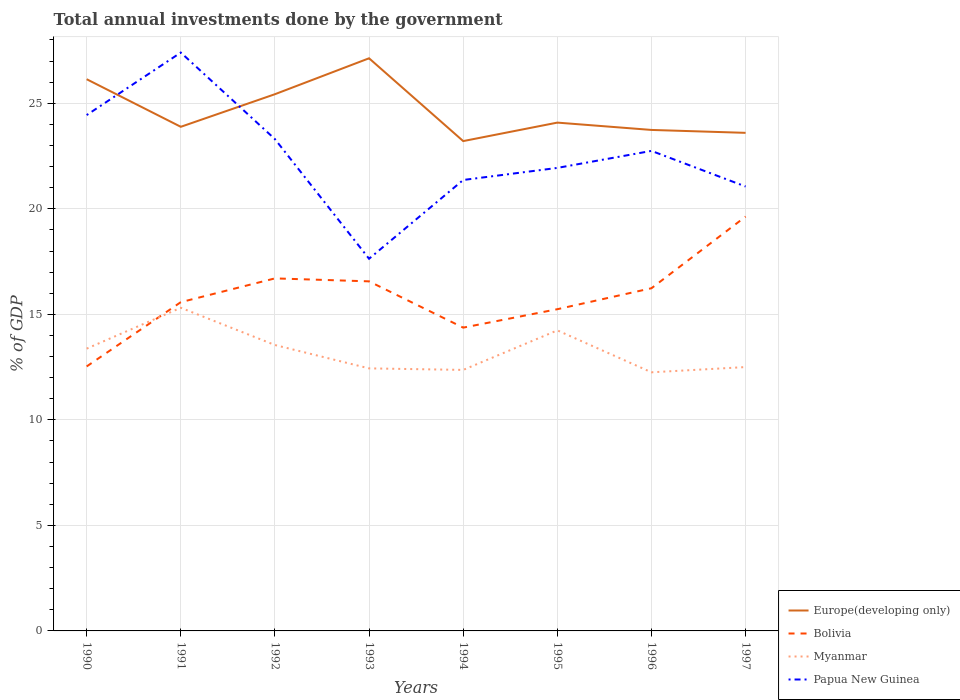Does the line corresponding to Papua New Guinea intersect with the line corresponding to Bolivia?
Make the answer very short. No. Across all years, what is the maximum total annual investments done by the government in Europe(developing only)?
Your response must be concise. 23.21. In which year was the total annual investments done by the government in Europe(developing only) maximum?
Give a very brief answer. 1994. What is the total total annual investments done by the government in Myanmar in the graph?
Your answer should be compact. 0.94. What is the difference between the highest and the second highest total annual investments done by the government in Papua New Guinea?
Offer a very short reply. 9.77. What is the difference between the highest and the lowest total annual investments done by the government in Bolivia?
Offer a very short reply. 4. Is the total annual investments done by the government in Myanmar strictly greater than the total annual investments done by the government in Papua New Guinea over the years?
Your answer should be very brief. Yes. How many years are there in the graph?
Keep it short and to the point. 8. Does the graph contain grids?
Your response must be concise. Yes. Where does the legend appear in the graph?
Keep it short and to the point. Bottom right. What is the title of the graph?
Ensure brevity in your answer.  Total annual investments done by the government. Does "Ecuador" appear as one of the legend labels in the graph?
Give a very brief answer. No. What is the label or title of the X-axis?
Your response must be concise. Years. What is the label or title of the Y-axis?
Your answer should be compact. % of GDP. What is the % of GDP in Europe(developing only) in 1990?
Provide a short and direct response. 26.14. What is the % of GDP of Bolivia in 1990?
Your answer should be very brief. 12.53. What is the % of GDP in Myanmar in 1990?
Your answer should be compact. 13.38. What is the % of GDP in Papua New Guinea in 1990?
Keep it short and to the point. 24.44. What is the % of GDP in Europe(developing only) in 1991?
Give a very brief answer. 23.89. What is the % of GDP of Bolivia in 1991?
Ensure brevity in your answer.  15.58. What is the % of GDP in Myanmar in 1991?
Ensure brevity in your answer.  15.31. What is the % of GDP in Papua New Guinea in 1991?
Your answer should be compact. 27.4. What is the % of GDP in Europe(developing only) in 1992?
Provide a succinct answer. 25.43. What is the % of GDP of Bolivia in 1992?
Give a very brief answer. 16.7. What is the % of GDP in Myanmar in 1992?
Give a very brief answer. 13.55. What is the % of GDP of Papua New Guinea in 1992?
Give a very brief answer. 23.3. What is the % of GDP in Europe(developing only) in 1993?
Your answer should be very brief. 27.13. What is the % of GDP of Bolivia in 1993?
Keep it short and to the point. 16.56. What is the % of GDP of Myanmar in 1993?
Give a very brief answer. 12.44. What is the % of GDP in Papua New Guinea in 1993?
Offer a terse response. 17.63. What is the % of GDP of Europe(developing only) in 1994?
Your answer should be compact. 23.21. What is the % of GDP in Bolivia in 1994?
Your answer should be compact. 14.37. What is the % of GDP of Myanmar in 1994?
Make the answer very short. 12.37. What is the % of GDP in Papua New Guinea in 1994?
Give a very brief answer. 21.37. What is the % of GDP of Europe(developing only) in 1995?
Offer a terse response. 24.09. What is the % of GDP of Bolivia in 1995?
Provide a short and direct response. 15.24. What is the % of GDP of Myanmar in 1995?
Keep it short and to the point. 14.24. What is the % of GDP of Papua New Guinea in 1995?
Offer a terse response. 21.94. What is the % of GDP in Europe(developing only) in 1996?
Keep it short and to the point. 23.74. What is the % of GDP in Bolivia in 1996?
Make the answer very short. 16.24. What is the % of GDP in Myanmar in 1996?
Provide a succinct answer. 12.25. What is the % of GDP in Papua New Guinea in 1996?
Your answer should be compact. 22.75. What is the % of GDP of Europe(developing only) in 1997?
Offer a very short reply. 23.6. What is the % of GDP of Bolivia in 1997?
Ensure brevity in your answer.  19.63. What is the % of GDP of Myanmar in 1997?
Offer a very short reply. 12.5. What is the % of GDP of Papua New Guinea in 1997?
Your answer should be very brief. 21.06. Across all years, what is the maximum % of GDP in Europe(developing only)?
Your answer should be compact. 27.13. Across all years, what is the maximum % of GDP of Bolivia?
Provide a short and direct response. 19.63. Across all years, what is the maximum % of GDP of Myanmar?
Offer a terse response. 15.31. Across all years, what is the maximum % of GDP in Papua New Guinea?
Make the answer very short. 27.4. Across all years, what is the minimum % of GDP in Europe(developing only)?
Offer a very short reply. 23.21. Across all years, what is the minimum % of GDP in Bolivia?
Provide a short and direct response. 12.53. Across all years, what is the minimum % of GDP in Myanmar?
Offer a very short reply. 12.25. Across all years, what is the minimum % of GDP in Papua New Guinea?
Provide a short and direct response. 17.63. What is the total % of GDP of Europe(developing only) in the graph?
Your response must be concise. 197.23. What is the total % of GDP of Bolivia in the graph?
Offer a terse response. 126.86. What is the total % of GDP of Myanmar in the graph?
Provide a succinct answer. 106.04. What is the total % of GDP of Papua New Guinea in the graph?
Offer a terse response. 179.89. What is the difference between the % of GDP in Europe(developing only) in 1990 and that in 1991?
Offer a very short reply. 2.26. What is the difference between the % of GDP in Bolivia in 1990 and that in 1991?
Offer a very short reply. -3.05. What is the difference between the % of GDP of Myanmar in 1990 and that in 1991?
Offer a terse response. -1.94. What is the difference between the % of GDP of Papua New Guinea in 1990 and that in 1991?
Offer a very short reply. -2.96. What is the difference between the % of GDP of Europe(developing only) in 1990 and that in 1992?
Your answer should be very brief. 0.71. What is the difference between the % of GDP in Bolivia in 1990 and that in 1992?
Your answer should be very brief. -4.17. What is the difference between the % of GDP of Myanmar in 1990 and that in 1992?
Your answer should be very brief. -0.17. What is the difference between the % of GDP of Papua New Guinea in 1990 and that in 1992?
Make the answer very short. 1.14. What is the difference between the % of GDP in Europe(developing only) in 1990 and that in 1993?
Your answer should be very brief. -0.99. What is the difference between the % of GDP of Bolivia in 1990 and that in 1993?
Your answer should be very brief. -4.03. What is the difference between the % of GDP of Myanmar in 1990 and that in 1993?
Your answer should be very brief. 0.94. What is the difference between the % of GDP of Papua New Guinea in 1990 and that in 1993?
Ensure brevity in your answer.  6.81. What is the difference between the % of GDP of Europe(developing only) in 1990 and that in 1994?
Make the answer very short. 2.93. What is the difference between the % of GDP of Bolivia in 1990 and that in 1994?
Your response must be concise. -1.84. What is the difference between the % of GDP in Papua New Guinea in 1990 and that in 1994?
Give a very brief answer. 3.08. What is the difference between the % of GDP in Europe(developing only) in 1990 and that in 1995?
Provide a succinct answer. 2.06. What is the difference between the % of GDP of Bolivia in 1990 and that in 1995?
Make the answer very short. -2.71. What is the difference between the % of GDP in Myanmar in 1990 and that in 1995?
Offer a very short reply. -0.87. What is the difference between the % of GDP in Papua New Guinea in 1990 and that in 1995?
Make the answer very short. 2.5. What is the difference between the % of GDP in Europe(developing only) in 1990 and that in 1996?
Make the answer very short. 2.4. What is the difference between the % of GDP in Bolivia in 1990 and that in 1996?
Offer a very short reply. -3.71. What is the difference between the % of GDP in Myanmar in 1990 and that in 1996?
Offer a terse response. 1.12. What is the difference between the % of GDP of Papua New Guinea in 1990 and that in 1996?
Keep it short and to the point. 1.7. What is the difference between the % of GDP in Europe(developing only) in 1990 and that in 1997?
Offer a very short reply. 2.54. What is the difference between the % of GDP of Myanmar in 1990 and that in 1997?
Make the answer very short. 0.87. What is the difference between the % of GDP in Papua New Guinea in 1990 and that in 1997?
Provide a short and direct response. 3.38. What is the difference between the % of GDP in Europe(developing only) in 1991 and that in 1992?
Offer a very short reply. -1.54. What is the difference between the % of GDP of Bolivia in 1991 and that in 1992?
Give a very brief answer. -1.13. What is the difference between the % of GDP in Myanmar in 1991 and that in 1992?
Make the answer very short. 1.76. What is the difference between the % of GDP in Papua New Guinea in 1991 and that in 1992?
Provide a short and direct response. 4.1. What is the difference between the % of GDP in Europe(developing only) in 1991 and that in 1993?
Your answer should be very brief. -3.25. What is the difference between the % of GDP of Bolivia in 1991 and that in 1993?
Ensure brevity in your answer.  -0.99. What is the difference between the % of GDP of Myanmar in 1991 and that in 1993?
Provide a short and direct response. 2.87. What is the difference between the % of GDP in Papua New Guinea in 1991 and that in 1993?
Your response must be concise. 9.77. What is the difference between the % of GDP of Europe(developing only) in 1991 and that in 1994?
Your response must be concise. 0.68. What is the difference between the % of GDP in Bolivia in 1991 and that in 1994?
Your answer should be compact. 1.21. What is the difference between the % of GDP in Myanmar in 1991 and that in 1994?
Ensure brevity in your answer.  2.94. What is the difference between the % of GDP of Papua New Guinea in 1991 and that in 1994?
Make the answer very short. 6.04. What is the difference between the % of GDP of Europe(developing only) in 1991 and that in 1995?
Ensure brevity in your answer.  -0.2. What is the difference between the % of GDP in Bolivia in 1991 and that in 1995?
Offer a terse response. 0.33. What is the difference between the % of GDP of Myanmar in 1991 and that in 1995?
Make the answer very short. 1.07. What is the difference between the % of GDP in Papua New Guinea in 1991 and that in 1995?
Give a very brief answer. 5.47. What is the difference between the % of GDP in Europe(developing only) in 1991 and that in 1996?
Your answer should be very brief. 0.15. What is the difference between the % of GDP of Bolivia in 1991 and that in 1996?
Your answer should be very brief. -0.66. What is the difference between the % of GDP of Myanmar in 1991 and that in 1996?
Ensure brevity in your answer.  3.06. What is the difference between the % of GDP of Papua New Guinea in 1991 and that in 1996?
Offer a very short reply. 4.66. What is the difference between the % of GDP of Europe(developing only) in 1991 and that in 1997?
Offer a very short reply. 0.29. What is the difference between the % of GDP in Bolivia in 1991 and that in 1997?
Keep it short and to the point. -4.05. What is the difference between the % of GDP in Myanmar in 1991 and that in 1997?
Your answer should be compact. 2.81. What is the difference between the % of GDP in Papua New Guinea in 1991 and that in 1997?
Keep it short and to the point. 6.35. What is the difference between the % of GDP of Europe(developing only) in 1992 and that in 1993?
Your response must be concise. -1.7. What is the difference between the % of GDP in Bolivia in 1992 and that in 1993?
Provide a succinct answer. 0.14. What is the difference between the % of GDP in Myanmar in 1992 and that in 1993?
Ensure brevity in your answer.  1.11. What is the difference between the % of GDP of Papua New Guinea in 1992 and that in 1993?
Keep it short and to the point. 5.67. What is the difference between the % of GDP of Europe(developing only) in 1992 and that in 1994?
Your answer should be compact. 2.22. What is the difference between the % of GDP of Bolivia in 1992 and that in 1994?
Your response must be concise. 2.33. What is the difference between the % of GDP in Myanmar in 1992 and that in 1994?
Make the answer very short. 1.18. What is the difference between the % of GDP in Papua New Guinea in 1992 and that in 1994?
Keep it short and to the point. 1.94. What is the difference between the % of GDP in Europe(developing only) in 1992 and that in 1995?
Offer a very short reply. 1.35. What is the difference between the % of GDP of Bolivia in 1992 and that in 1995?
Provide a succinct answer. 1.46. What is the difference between the % of GDP of Myanmar in 1992 and that in 1995?
Your answer should be compact. -0.69. What is the difference between the % of GDP of Papua New Guinea in 1992 and that in 1995?
Ensure brevity in your answer.  1.36. What is the difference between the % of GDP in Europe(developing only) in 1992 and that in 1996?
Offer a terse response. 1.69. What is the difference between the % of GDP in Bolivia in 1992 and that in 1996?
Provide a succinct answer. 0.47. What is the difference between the % of GDP in Myanmar in 1992 and that in 1996?
Keep it short and to the point. 1.29. What is the difference between the % of GDP in Papua New Guinea in 1992 and that in 1996?
Offer a very short reply. 0.56. What is the difference between the % of GDP in Europe(developing only) in 1992 and that in 1997?
Provide a short and direct response. 1.83. What is the difference between the % of GDP of Bolivia in 1992 and that in 1997?
Provide a short and direct response. -2.93. What is the difference between the % of GDP in Myanmar in 1992 and that in 1997?
Your answer should be compact. 1.04. What is the difference between the % of GDP in Papua New Guinea in 1992 and that in 1997?
Give a very brief answer. 2.25. What is the difference between the % of GDP of Europe(developing only) in 1993 and that in 1994?
Offer a very short reply. 3.92. What is the difference between the % of GDP in Bolivia in 1993 and that in 1994?
Provide a succinct answer. 2.19. What is the difference between the % of GDP of Myanmar in 1993 and that in 1994?
Provide a short and direct response. 0.07. What is the difference between the % of GDP in Papua New Guinea in 1993 and that in 1994?
Give a very brief answer. -3.73. What is the difference between the % of GDP in Europe(developing only) in 1993 and that in 1995?
Your response must be concise. 3.05. What is the difference between the % of GDP in Bolivia in 1993 and that in 1995?
Give a very brief answer. 1.32. What is the difference between the % of GDP in Myanmar in 1993 and that in 1995?
Offer a very short reply. -1.8. What is the difference between the % of GDP in Papua New Guinea in 1993 and that in 1995?
Provide a succinct answer. -4.3. What is the difference between the % of GDP of Europe(developing only) in 1993 and that in 1996?
Give a very brief answer. 3.4. What is the difference between the % of GDP of Bolivia in 1993 and that in 1996?
Provide a succinct answer. 0.33. What is the difference between the % of GDP in Myanmar in 1993 and that in 1996?
Make the answer very short. 0.19. What is the difference between the % of GDP of Papua New Guinea in 1993 and that in 1996?
Give a very brief answer. -5.11. What is the difference between the % of GDP of Europe(developing only) in 1993 and that in 1997?
Your response must be concise. 3.53. What is the difference between the % of GDP in Bolivia in 1993 and that in 1997?
Ensure brevity in your answer.  -3.07. What is the difference between the % of GDP in Myanmar in 1993 and that in 1997?
Provide a short and direct response. -0.06. What is the difference between the % of GDP in Papua New Guinea in 1993 and that in 1997?
Ensure brevity in your answer.  -3.42. What is the difference between the % of GDP of Europe(developing only) in 1994 and that in 1995?
Ensure brevity in your answer.  -0.88. What is the difference between the % of GDP in Bolivia in 1994 and that in 1995?
Provide a short and direct response. -0.87. What is the difference between the % of GDP in Myanmar in 1994 and that in 1995?
Provide a succinct answer. -1.87. What is the difference between the % of GDP of Papua New Guinea in 1994 and that in 1995?
Offer a very short reply. -0.57. What is the difference between the % of GDP of Europe(developing only) in 1994 and that in 1996?
Keep it short and to the point. -0.53. What is the difference between the % of GDP of Bolivia in 1994 and that in 1996?
Your answer should be compact. -1.87. What is the difference between the % of GDP in Myanmar in 1994 and that in 1996?
Provide a succinct answer. 0.11. What is the difference between the % of GDP of Papua New Guinea in 1994 and that in 1996?
Give a very brief answer. -1.38. What is the difference between the % of GDP in Europe(developing only) in 1994 and that in 1997?
Your answer should be very brief. -0.39. What is the difference between the % of GDP in Bolivia in 1994 and that in 1997?
Offer a very short reply. -5.26. What is the difference between the % of GDP in Myanmar in 1994 and that in 1997?
Make the answer very short. -0.13. What is the difference between the % of GDP in Papua New Guinea in 1994 and that in 1997?
Your response must be concise. 0.31. What is the difference between the % of GDP of Europe(developing only) in 1995 and that in 1996?
Offer a terse response. 0.35. What is the difference between the % of GDP in Bolivia in 1995 and that in 1996?
Offer a terse response. -0.99. What is the difference between the % of GDP of Myanmar in 1995 and that in 1996?
Make the answer very short. 1.99. What is the difference between the % of GDP in Papua New Guinea in 1995 and that in 1996?
Your answer should be very brief. -0.81. What is the difference between the % of GDP of Europe(developing only) in 1995 and that in 1997?
Your answer should be very brief. 0.48. What is the difference between the % of GDP of Bolivia in 1995 and that in 1997?
Make the answer very short. -4.39. What is the difference between the % of GDP of Myanmar in 1995 and that in 1997?
Your answer should be compact. 1.74. What is the difference between the % of GDP of Papua New Guinea in 1995 and that in 1997?
Offer a terse response. 0.88. What is the difference between the % of GDP of Europe(developing only) in 1996 and that in 1997?
Provide a succinct answer. 0.14. What is the difference between the % of GDP in Bolivia in 1996 and that in 1997?
Make the answer very short. -3.39. What is the difference between the % of GDP in Myanmar in 1996 and that in 1997?
Your answer should be very brief. -0.25. What is the difference between the % of GDP of Papua New Guinea in 1996 and that in 1997?
Your answer should be very brief. 1.69. What is the difference between the % of GDP in Europe(developing only) in 1990 and the % of GDP in Bolivia in 1991?
Provide a succinct answer. 10.56. What is the difference between the % of GDP in Europe(developing only) in 1990 and the % of GDP in Myanmar in 1991?
Offer a very short reply. 10.83. What is the difference between the % of GDP of Europe(developing only) in 1990 and the % of GDP of Papua New Guinea in 1991?
Give a very brief answer. -1.26. What is the difference between the % of GDP of Bolivia in 1990 and the % of GDP of Myanmar in 1991?
Your answer should be very brief. -2.78. What is the difference between the % of GDP in Bolivia in 1990 and the % of GDP in Papua New Guinea in 1991?
Ensure brevity in your answer.  -14.87. What is the difference between the % of GDP in Myanmar in 1990 and the % of GDP in Papua New Guinea in 1991?
Your response must be concise. -14.03. What is the difference between the % of GDP of Europe(developing only) in 1990 and the % of GDP of Bolivia in 1992?
Provide a succinct answer. 9.44. What is the difference between the % of GDP of Europe(developing only) in 1990 and the % of GDP of Myanmar in 1992?
Keep it short and to the point. 12.6. What is the difference between the % of GDP of Europe(developing only) in 1990 and the % of GDP of Papua New Guinea in 1992?
Provide a succinct answer. 2.84. What is the difference between the % of GDP in Bolivia in 1990 and the % of GDP in Myanmar in 1992?
Provide a succinct answer. -1.02. What is the difference between the % of GDP in Bolivia in 1990 and the % of GDP in Papua New Guinea in 1992?
Provide a succinct answer. -10.77. What is the difference between the % of GDP of Myanmar in 1990 and the % of GDP of Papua New Guinea in 1992?
Provide a short and direct response. -9.93. What is the difference between the % of GDP of Europe(developing only) in 1990 and the % of GDP of Bolivia in 1993?
Your answer should be very brief. 9.58. What is the difference between the % of GDP in Europe(developing only) in 1990 and the % of GDP in Myanmar in 1993?
Your answer should be very brief. 13.7. What is the difference between the % of GDP of Europe(developing only) in 1990 and the % of GDP of Papua New Guinea in 1993?
Keep it short and to the point. 8.51. What is the difference between the % of GDP in Bolivia in 1990 and the % of GDP in Myanmar in 1993?
Offer a terse response. 0.09. What is the difference between the % of GDP in Bolivia in 1990 and the % of GDP in Papua New Guinea in 1993?
Make the answer very short. -5.1. What is the difference between the % of GDP in Myanmar in 1990 and the % of GDP in Papua New Guinea in 1993?
Keep it short and to the point. -4.26. What is the difference between the % of GDP of Europe(developing only) in 1990 and the % of GDP of Bolivia in 1994?
Ensure brevity in your answer.  11.77. What is the difference between the % of GDP in Europe(developing only) in 1990 and the % of GDP in Myanmar in 1994?
Ensure brevity in your answer.  13.77. What is the difference between the % of GDP of Europe(developing only) in 1990 and the % of GDP of Papua New Guinea in 1994?
Keep it short and to the point. 4.78. What is the difference between the % of GDP of Bolivia in 1990 and the % of GDP of Myanmar in 1994?
Give a very brief answer. 0.16. What is the difference between the % of GDP in Bolivia in 1990 and the % of GDP in Papua New Guinea in 1994?
Your answer should be compact. -8.83. What is the difference between the % of GDP in Myanmar in 1990 and the % of GDP in Papua New Guinea in 1994?
Provide a short and direct response. -7.99. What is the difference between the % of GDP of Europe(developing only) in 1990 and the % of GDP of Bolivia in 1995?
Ensure brevity in your answer.  10.9. What is the difference between the % of GDP of Europe(developing only) in 1990 and the % of GDP of Myanmar in 1995?
Keep it short and to the point. 11.9. What is the difference between the % of GDP of Europe(developing only) in 1990 and the % of GDP of Papua New Guinea in 1995?
Your answer should be compact. 4.2. What is the difference between the % of GDP in Bolivia in 1990 and the % of GDP in Myanmar in 1995?
Make the answer very short. -1.71. What is the difference between the % of GDP of Bolivia in 1990 and the % of GDP of Papua New Guinea in 1995?
Make the answer very short. -9.41. What is the difference between the % of GDP in Myanmar in 1990 and the % of GDP in Papua New Guinea in 1995?
Your answer should be very brief. -8.56. What is the difference between the % of GDP in Europe(developing only) in 1990 and the % of GDP in Bolivia in 1996?
Offer a very short reply. 9.9. What is the difference between the % of GDP of Europe(developing only) in 1990 and the % of GDP of Myanmar in 1996?
Provide a short and direct response. 13.89. What is the difference between the % of GDP of Europe(developing only) in 1990 and the % of GDP of Papua New Guinea in 1996?
Offer a terse response. 3.4. What is the difference between the % of GDP in Bolivia in 1990 and the % of GDP in Myanmar in 1996?
Offer a very short reply. 0.28. What is the difference between the % of GDP of Bolivia in 1990 and the % of GDP of Papua New Guinea in 1996?
Your answer should be very brief. -10.21. What is the difference between the % of GDP of Myanmar in 1990 and the % of GDP of Papua New Guinea in 1996?
Give a very brief answer. -9.37. What is the difference between the % of GDP of Europe(developing only) in 1990 and the % of GDP of Bolivia in 1997?
Provide a succinct answer. 6.51. What is the difference between the % of GDP of Europe(developing only) in 1990 and the % of GDP of Myanmar in 1997?
Offer a very short reply. 13.64. What is the difference between the % of GDP in Europe(developing only) in 1990 and the % of GDP in Papua New Guinea in 1997?
Your answer should be compact. 5.08. What is the difference between the % of GDP of Bolivia in 1990 and the % of GDP of Myanmar in 1997?
Your answer should be very brief. 0.03. What is the difference between the % of GDP in Bolivia in 1990 and the % of GDP in Papua New Guinea in 1997?
Your answer should be very brief. -8.53. What is the difference between the % of GDP of Myanmar in 1990 and the % of GDP of Papua New Guinea in 1997?
Offer a very short reply. -7.68. What is the difference between the % of GDP of Europe(developing only) in 1991 and the % of GDP of Bolivia in 1992?
Offer a very short reply. 7.18. What is the difference between the % of GDP of Europe(developing only) in 1991 and the % of GDP of Myanmar in 1992?
Your answer should be very brief. 10.34. What is the difference between the % of GDP in Europe(developing only) in 1991 and the % of GDP in Papua New Guinea in 1992?
Ensure brevity in your answer.  0.58. What is the difference between the % of GDP in Bolivia in 1991 and the % of GDP in Myanmar in 1992?
Offer a very short reply. 2.03. What is the difference between the % of GDP of Bolivia in 1991 and the % of GDP of Papua New Guinea in 1992?
Offer a very short reply. -7.73. What is the difference between the % of GDP in Myanmar in 1991 and the % of GDP in Papua New Guinea in 1992?
Offer a very short reply. -7.99. What is the difference between the % of GDP of Europe(developing only) in 1991 and the % of GDP of Bolivia in 1993?
Make the answer very short. 7.32. What is the difference between the % of GDP in Europe(developing only) in 1991 and the % of GDP in Myanmar in 1993?
Keep it short and to the point. 11.45. What is the difference between the % of GDP of Europe(developing only) in 1991 and the % of GDP of Papua New Guinea in 1993?
Give a very brief answer. 6.25. What is the difference between the % of GDP in Bolivia in 1991 and the % of GDP in Myanmar in 1993?
Offer a very short reply. 3.14. What is the difference between the % of GDP of Bolivia in 1991 and the % of GDP of Papua New Guinea in 1993?
Your answer should be very brief. -2.06. What is the difference between the % of GDP in Myanmar in 1991 and the % of GDP in Papua New Guinea in 1993?
Keep it short and to the point. -2.32. What is the difference between the % of GDP of Europe(developing only) in 1991 and the % of GDP of Bolivia in 1994?
Offer a terse response. 9.52. What is the difference between the % of GDP of Europe(developing only) in 1991 and the % of GDP of Myanmar in 1994?
Offer a very short reply. 11.52. What is the difference between the % of GDP of Europe(developing only) in 1991 and the % of GDP of Papua New Guinea in 1994?
Make the answer very short. 2.52. What is the difference between the % of GDP of Bolivia in 1991 and the % of GDP of Myanmar in 1994?
Ensure brevity in your answer.  3.21. What is the difference between the % of GDP in Bolivia in 1991 and the % of GDP in Papua New Guinea in 1994?
Your response must be concise. -5.79. What is the difference between the % of GDP in Myanmar in 1991 and the % of GDP in Papua New Guinea in 1994?
Ensure brevity in your answer.  -6.05. What is the difference between the % of GDP of Europe(developing only) in 1991 and the % of GDP of Bolivia in 1995?
Offer a very short reply. 8.64. What is the difference between the % of GDP of Europe(developing only) in 1991 and the % of GDP of Myanmar in 1995?
Keep it short and to the point. 9.65. What is the difference between the % of GDP in Europe(developing only) in 1991 and the % of GDP in Papua New Guinea in 1995?
Your answer should be compact. 1.95. What is the difference between the % of GDP of Bolivia in 1991 and the % of GDP of Myanmar in 1995?
Your response must be concise. 1.34. What is the difference between the % of GDP in Bolivia in 1991 and the % of GDP in Papua New Guinea in 1995?
Keep it short and to the point. -6.36. What is the difference between the % of GDP of Myanmar in 1991 and the % of GDP of Papua New Guinea in 1995?
Your answer should be compact. -6.63. What is the difference between the % of GDP in Europe(developing only) in 1991 and the % of GDP in Bolivia in 1996?
Ensure brevity in your answer.  7.65. What is the difference between the % of GDP of Europe(developing only) in 1991 and the % of GDP of Myanmar in 1996?
Your answer should be compact. 11.63. What is the difference between the % of GDP of Europe(developing only) in 1991 and the % of GDP of Papua New Guinea in 1996?
Give a very brief answer. 1.14. What is the difference between the % of GDP of Bolivia in 1991 and the % of GDP of Myanmar in 1996?
Offer a very short reply. 3.32. What is the difference between the % of GDP in Bolivia in 1991 and the % of GDP in Papua New Guinea in 1996?
Offer a very short reply. -7.17. What is the difference between the % of GDP in Myanmar in 1991 and the % of GDP in Papua New Guinea in 1996?
Give a very brief answer. -7.43. What is the difference between the % of GDP in Europe(developing only) in 1991 and the % of GDP in Bolivia in 1997?
Make the answer very short. 4.25. What is the difference between the % of GDP in Europe(developing only) in 1991 and the % of GDP in Myanmar in 1997?
Offer a very short reply. 11.38. What is the difference between the % of GDP of Europe(developing only) in 1991 and the % of GDP of Papua New Guinea in 1997?
Offer a terse response. 2.83. What is the difference between the % of GDP of Bolivia in 1991 and the % of GDP of Myanmar in 1997?
Provide a short and direct response. 3.08. What is the difference between the % of GDP of Bolivia in 1991 and the % of GDP of Papua New Guinea in 1997?
Make the answer very short. -5.48. What is the difference between the % of GDP in Myanmar in 1991 and the % of GDP in Papua New Guinea in 1997?
Provide a short and direct response. -5.75. What is the difference between the % of GDP of Europe(developing only) in 1992 and the % of GDP of Bolivia in 1993?
Your answer should be compact. 8.87. What is the difference between the % of GDP of Europe(developing only) in 1992 and the % of GDP of Myanmar in 1993?
Provide a succinct answer. 12.99. What is the difference between the % of GDP of Europe(developing only) in 1992 and the % of GDP of Papua New Guinea in 1993?
Give a very brief answer. 7.8. What is the difference between the % of GDP in Bolivia in 1992 and the % of GDP in Myanmar in 1993?
Keep it short and to the point. 4.26. What is the difference between the % of GDP of Bolivia in 1992 and the % of GDP of Papua New Guinea in 1993?
Your answer should be compact. -0.93. What is the difference between the % of GDP in Myanmar in 1992 and the % of GDP in Papua New Guinea in 1993?
Make the answer very short. -4.09. What is the difference between the % of GDP of Europe(developing only) in 1992 and the % of GDP of Bolivia in 1994?
Provide a succinct answer. 11.06. What is the difference between the % of GDP of Europe(developing only) in 1992 and the % of GDP of Myanmar in 1994?
Your response must be concise. 13.06. What is the difference between the % of GDP in Europe(developing only) in 1992 and the % of GDP in Papua New Guinea in 1994?
Your response must be concise. 4.06. What is the difference between the % of GDP of Bolivia in 1992 and the % of GDP of Myanmar in 1994?
Provide a succinct answer. 4.34. What is the difference between the % of GDP of Bolivia in 1992 and the % of GDP of Papua New Guinea in 1994?
Keep it short and to the point. -4.66. What is the difference between the % of GDP of Myanmar in 1992 and the % of GDP of Papua New Guinea in 1994?
Give a very brief answer. -7.82. What is the difference between the % of GDP in Europe(developing only) in 1992 and the % of GDP in Bolivia in 1995?
Provide a short and direct response. 10.19. What is the difference between the % of GDP of Europe(developing only) in 1992 and the % of GDP of Myanmar in 1995?
Keep it short and to the point. 11.19. What is the difference between the % of GDP in Europe(developing only) in 1992 and the % of GDP in Papua New Guinea in 1995?
Your response must be concise. 3.49. What is the difference between the % of GDP in Bolivia in 1992 and the % of GDP in Myanmar in 1995?
Offer a very short reply. 2.46. What is the difference between the % of GDP in Bolivia in 1992 and the % of GDP in Papua New Guinea in 1995?
Offer a very short reply. -5.23. What is the difference between the % of GDP in Myanmar in 1992 and the % of GDP in Papua New Guinea in 1995?
Give a very brief answer. -8.39. What is the difference between the % of GDP of Europe(developing only) in 1992 and the % of GDP of Bolivia in 1996?
Offer a terse response. 9.19. What is the difference between the % of GDP in Europe(developing only) in 1992 and the % of GDP in Myanmar in 1996?
Your answer should be very brief. 13.18. What is the difference between the % of GDP in Europe(developing only) in 1992 and the % of GDP in Papua New Guinea in 1996?
Your response must be concise. 2.69. What is the difference between the % of GDP in Bolivia in 1992 and the % of GDP in Myanmar in 1996?
Offer a terse response. 4.45. What is the difference between the % of GDP in Bolivia in 1992 and the % of GDP in Papua New Guinea in 1996?
Ensure brevity in your answer.  -6.04. What is the difference between the % of GDP in Myanmar in 1992 and the % of GDP in Papua New Guinea in 1996?
Keep it short and to the point. -9.2. What is the difference between the % of GDP of Europe(developing only) in 1992 and the % of GDP of Bolivia in 1997?
Offer a very short reply. 5.8. What is the difference between the % of GDP in Europe(developing only) in 1992 and the % of GDP in Myanmar in 1997?
Offer a terse response. 12.93. What is the difference between the % of GDP in Europe(developing only) in 1992 and the % of GDP in Papua New Guinea in 1997?
Make the answer very short. 4.37. What is the difference between the % of GDP of Bolivia in 1992 and the % of GDP of Myanmar in 1997?
Give a very brief answer. 4.2. What is the difference between the % of GDP of Bolivia in 1992 and the % of GDP of Papua New Guinea in 1997?
Offer a terse response. -4.35. What is the difference between the % of GDP in Myanmar in 1992 and the % of GDP in Papua New Guinea in 1997?
Provide a succinct answer. -7.51. What is the difference between the % of GDP in Europe(developing only) in 1993 and the % of GDP in Bolivia in 1994?
Give a very brief answer. 12.76. What is the difference between the % of GDP of Europe(developing only) in 1993 and the % of GDP of Myanmar in 1994?
Provide a succinct answer. 14.77. What is the difference between the % of GDP in Europe(developing only) in 1993 and the % of GDP in Papua New Guinea in 1994?
Your answer should be very brief. 5.77. What is the difference between the % of GDP in Bolivia in 1993 and the % of GDP in Myanmar in 1994?
Your response must be concise. 4.2. What is the difference between the % of GDP in Bolivia in 1993 and the % of GDP in Papua New Guinea in 1994?
Ensure brevity in your answer.  -4.8. What is the difference between the % of GDP in Myanmar in 1993 and the % of GDP in Papua New Guinea in 1994?
Make the answer very short. -8.93. What is the difference between the % of GDP in Europe(developing only) in 1993 and the % of GDP in Bolivia in 1995?
Offer a terse response. 11.89. What is the difference between the % of GDP of Europe(developing only) in 1993 and the % of GDP of Myanmar in 1995?
Ensure brevity in your answer.  12.89. What is the difference between the % of GDP in Europe(developing only) in 1993 and the % of GDP in Papua New Guinea in 1995?
Provide a short and direct response. 5.19. What is the difference between the % of GDP of Bolivia in 1993 and the % of GDP of Myanmar in 1995?
Ensure brevity in your answer.  2.32. What is the difference between the % of GDP in Bolivia in 1993 and the % of GDP in Papua New Guinea in 1995?
Your answer should be very brief. -5.38. What is the difference between the % of GDP in Myanmar in 1993 and the % of GDP in Papua New Guinea in 1995?
Keep it short and to the point. -9.5. What is the difference between the % of GDP in Europe(developing only) in 1993 and the % of GDP in Bolivia in 1996?
Your answer should be compact. 10.9. What is the difference between the % of GDP of Europe(developing only) in 1993 and the % of GDP of Myanmar in 1996?
Offer a terse response. 14.88. What is the difference between the % of GDP of Europe(developing only) in 1993 and the % of GDP of Papua New Guinea in 1996?
Provide a short and direct response. 4.39. What is the difference between the % of GDP of Bolivia in 1993 and the % of GDP of Myanmar in 1996?
Your answer should be very brief. 4.31. What is the difference between the % of GDP of Bolivia in 1993 and the % of GDP of Papua New Guinea in 1996?
Provide a short and direct response. -6.18. What is the difference between the % of GDP of Myanmar in 1993 and the % of GDP of Papua New Guinea in 1996?
Provide a succinct answer. -10.3. What is the difference between the % of GDP of Europe(developing only) in 1993 and the % of GDP of Bolivia in 1997?
Ensure brevity in your answer.  7.5. What is the difference between the % of GDP in Europe(developing only) in 1993 and the % of GDP in Myanmar in 1997?
Ensure brevity in your answer.  14.63. What is the difference between the % of GDP in Europe(developing only) in 1993 and the % of GDP in Papua New Guinea in 1997?
Ensure brevity in your answer.  6.08. What is the difference between the % of GDP in Bolivia in 1993 and the % of GDP in Myanmar in 1997?
Make the answer very short. 4.06. What is the difference between the % of GDP in Bolivia in 1993 and the % of GDP in Papua New Guinea in 1997?
Your answer should be compact. -4.49. What is the difference between the % of GDP in Myanmar in 1993 and the % of GDP in Papua New Guinea in 1997?
Provide a short and direct response. -8.62. What is the difference between the % of GDP in Europe(developing only) in 1994 and the % of GDP in Bolivia in 1995?
Provide a short and direct response. 7.97. What is the difference between the % of GDP of Europe(developing only) in 1994 and the % of GDP of Myanmar in 1995?
Your response must be concise. 8.97. What is the difference between the % of GDP in Europe(developing only) in 1994 and the % of GDP in Papua New Guinea in 1995?
Keep it short and to the point. 1.27. What is the difference between the % of GDP in Bolivia in 1994 and the % of GDP in Myanmar in 1995?
Your answer should be very brief. 0.13. What is the difference between the % of GDP in Bolivia in 1994 and the % of GDP in Papua New Guinea in 1995?
Your answer should be compact. -7.57. What is the difference between the % of GDP in Myanmar in 1994 and the % of GDP in Papua New Guinea in 1995?
Make the answer very short. -9.57. What is the difference between the % of GDP in Europe(developing only) in 1994 and the % of GDP in Bolivia in 1996?
Offer a terse response. 6.97. What is the difference between the % of GDP of Europe(developing only) in 1994 and the % of GDP of Myanmar in 1996?
Keep it short and to the point. 10.96. What is the difference between the % of GDP of Europe(developing only) in 1994 and the % of GDP of Papua New Guinea in 1996?
Keep it short and to the point. 0.46. What is the difference between the % of GDP of Bolivia in 1994 and the % of GDP of Myanmar in 1996?
Make the answer very short. 2.12. What is the difference between the % of GDP in Bolivia in 1994 and the % of GDP in Papua New Guinea in 1996?
Keep it short and to the point. -8.37. What is the difference between the % of GDP of Myanmar in 1994 and the % of GDP of Papua New Guinea in 1996?
Your answer should be compact. -10.38. What is the difference between the % of GDP of Europe(developing only) in 1994 and the % of GDP of Bolivia in 1997?
Keep it short and to the point. 3.58. What is the difference between the % of GDP in Europe(developing only) in 1994 and the % of GDP in Myanmar in 1997?
Give a very brief answer. 10.71. What is the difference between the % of GDP of Europe(developing only) in 1994 and the % of GDP of Papua New Guinea in 1997?
Your answer should be very brief. 2.15. What is the difference between the % of GDP in Bolivia in 1994 and the % of GDP in Myanmar in 1997?
Make the answer very short. 1.87. What is the difference between the % of GDP in Bolivia in 1994 and the % of GDP in Papua New Guinea in 1997?
Provide a succinct answer. -6.69. What is the difference between the % of GDP in Myanmar in 1994 and the % of GDP in Papua New Guinea in 1997?
Provide a short and direct response. -8.69. What is the difference between the % of GDP of Europe(developing only) in 1995 and the % of GDP of Bolivia in 1996?
Your answer should be compact. 7.85. What is the difference between the % of GDP of Europe(developing only) in 1995 and the % of GDP of Myanmar in 1996?
Your answer should be very brief. 11.83. What is the difference between the % of GDP in Europe(developing only) in 1995 and the % of GDP in Papua New Guinea in 1996?
Your response must be concise. 1.34. What is the difference between the % of GDP in Bolivia in 1995 and the % of GDP in Myanmar in 1996?
Provide a short and direct response. 2.99. What is the difference between the % of GDP in Bolivia in 1995 and the % of GDP in Papua New Guinea in 1996?
Keep it short and to the point. -7.5. What is the difference between the % of GDP in Myanmar in 1995 and the % of GDP in Papua New Guinea in 1996?
Your answer should be compact. -8.5. What is the difference between the % of GDP of Europe(developing only) in 1995 and the % of GDP of Bolivia in 1997?
Your response must be concise. 4.45. What is the difference between the % of GDP in Europe(developing only) in 1995 and the % of GDP in Myanmar in 1997?
Ensure brevity in your answer.  11.58. What is the difference between the % of GDP in Europe(developing only) in 1995 and the % of GDP in Papua New Guinea in 1997?
Offer a very short reply. 3.03. What is the difference between the % of GDP of Bolivia in 1995 and the % of GDP of Myanmar in 1997?
Offer a very short reply. 2.74. What is the difference between the % of GDP of Bolivia in 1995 and the % of GDP of Papua New Guinea in 1997?
Offer a very short reply. -5.81. What is the difference between the % of GDP of Myanmar in 1995 and the % of GDP of Papua New Guinea in 1997?
Provide a succinct answer. -6.82. What is the difference between the % of GDP of Europe(developing only) in 1996 and the % of GDP of Bolivia in 1997?
Make the answer very short. 4.11. What is the difference between the % of GDP of Europe(developing only) in 1996 and the % of GDP of Myanmar in 1997?
Give a very brief answer. 11.24. What is the difference between the % of GDP of Europe(developing only) in 1996 and the % of GDP of Papua New Guinea in 1997?
Offer a terse response. 2.68. What is the difference between the % of GDP in Bolivia in 1996 and the % of GDP in Myanmar in 1997?
Provide a succinct answer. 3.73. What is the difference between the % of GDP in Bolivia in 1996 and the % of GDP in Papua New Guinea in 1997?
Provide a short and direct response. -4.82. What is the difference between the % of GDP in Myanmar in 1996 and the % of GDP in Papua New Guinea in 1997?
Keep it short and to the point. -8.8. What is the average % of GDP of Europe(developing only) per year?
Your answer should be compact. 24.65. What is the average % of GDP in Bolivia per year?
Offer a very short reply. 15.86. What is the average % of GDP of Myanmar per year?
Provide a short and direct response. 13.26. What is the average % of GDP of Papua New Guinea per year?
Provide a short and direct response. 22.49. In the year 1990, what is the difference between the % of GDP of Europe(developing only) and % of GDP of Bolivia?
Your answer should be compact. 13.61. In the year 1990, what is the difference between the % of GDP of Europe(developing only) and % of GDP of Myanmar?
Provide a succinct answer. 12.77. In the year 1990, what is the difference between the % of GDP in Europe(developing only) and % of GDP in Papua New Guinea?
Ensure brevity in your answer.  1.7. In the year 1990, what is the difference between the % of GDP of Bolivia and % of GDP of Myanmar?
Your answer should be very brief. -0.84. In the year 1990, what is the difference between the % of GDP of Bolivia and % of GDP of Papua New Guinea?
Keep it short and to the point. -11.91. In the year 1990, what is the difference between the % of GDP in Myanmar and % of GDP in Papua New Guinea?
Give a very brief answer. -11.07. In the year 1991, what is the difference between the % of GDP in Europe(developing only) and % of GDP in Bolivia?
Give a very brief answer. 8.31. In the year 1991, what is the difference between the % of GDP of Europe(developing only) and % of GDP of Myanmar?
Make the answer very short. 8.57. In the year 1991, what is the difference between the % of GDP of Europe(developing only) and % of GDP of Papua New Guinea?
Provide a succinct answer. -3.52. In the year 1991, what is the difference between the % of GDP of Bolivia and % of GDP of Myanmar?
Provide a short and direct response. 0.27. In the year 1991, what is the difference between the % of GDP in Bolivia and % of GDP in Papua New Guinea?
Offer a very short reply. -11.83. In the year 1991, what is the difference between the % of GDP of Myanmar and % of GDP of Papua New Guinea?
Your answer should be compact. -12.09. In the year 1992, what is the difference between the % of GDP of Europe(developing only) and % of GDP of Bolivia?
Your answer should be very brief. 8.73. In the year 1992, what is the difference between the % of GDP in Europe(developing only) and % of GDP in Myanmar?
Provide a succinct answer. 11.88. In the year 1992, what is the difference between the % of GDP in Europe(developing only) and % of GDP in Papua New Guinea?
Offer a terse response. 2.13. In the year 1992, what is the difference between the % of GDP of Bolivia and % of GDP of Myanmar?
Your answer should be compact. 3.16. In the year 1992, what is the difference between the % of GDP of Bolivia and % of GDP of Papua New Guinea?
Keep it short and to the point. -6.6. In the year 1992, what is the difference between the % of GDP in Myanmar and % of GDP in Papua New Guinea?
Your answer should be compact. -9.76. In the year 1993, what is the difference between the % of GDP of Europe(developing only) and % of GDP of Bolivia?
Offer a very short reply. 10.57. In the year 1993, what is the difference between the % of GDP in Europe(developing only) and % of GDP in Myanmar?
Ensure brevity in your answer.  14.69. In the year 1993, what is the difference between the % of GDP of Europe(developing only) and % of GDP of Papua New Guinea?
Make the answer very short. 9.5. In the year 1993, what is the difference between the % of GDP in Bolivia and % of GDP in Myanmar?
Keep it short and to the point. 4.12. In the year 1993, what is the difference between the % of GDP in Bolivia and % of GDP in Papua New Guinea?
Offer a terse response. -1.07. In the year 1993, what is the difference between the % of GDP in Myanmar and % of GDP in Papua New Guinea?
Your answer should be compact. -5.19. In the year 1994, what is the difference between the % of GDP of Europe(developing only) and % of GDP of Bolivia?
Make the answer very short. 8.84. In the year 1994, what is the difference between the % of GDP in Europe(developing only) and % of GDP in Myanmar?
Provide a short and direct response. 10.84. In the year 1994, what is the difference between the % of GDP of Europe(developing only) and % of GDP of Papua New Guinea?
Your answer should be compact. 1.84. In the year 1994, what is the difference between the % of GDP of Bolivia and % of GDP of Myanmar?
Your answer should be very brief. 2. In the year 1994, what is the difference between the % of GDP of Bolivia and % of GDP of Papua New Guinea?
Make the answer very short. -7. In the year 1994, what is the difference between the % of GDP of Myanmar and % of GDP of Papua New Guinea?
Offer a very short reply. -9. In the year 1995, what is the difference between the % of GDP in Europe(developing only) and % of GDP in Bolivia?
Offer a very short reply. 8.84. In the year 1995, what is the difference between the % of GDP in Europe(developing only) and % of GDP in Myanmar?
Keep it short and to the point. 9.84. In the year 1995, what is the difference between the % of GDP of Europe(developing only) and % of GDP of Papua New Guinea?
Keep it short and to the point. 2.15. In the year 1995, what is the difference between the % of GDP in Bolivia and % of GDP in Papua New Guinea?
Your answer should be compact. -6.7. In the year 1995, what is the difference between the % of GDP in Myanmar and % of GDP in Papua New Guinea?
Your answer should be compact. -7.7. In the year 1996, what is the difference between the % of GDP of Europe(developing only) and % of GDP of Bolivia?
Make the answer very short. 7.5. In the year 1996, what is the difference between the % of GDP in Europe(developing only) and % of GDP in Myanmar?
Make the answer very short. 11.48. In the year 1996, what is the difference between the % of GDP of Europe(developing only) and % of GDP of Papua New Guinea?
Keep it short and to the point. 0.99. In the year 1996, what is the difference between the % of GDP of Bolivia and % of GDP of Myanmar?
Keep it short and to the point. 3.98. In the year 1996, what is the difference between the % of GDP of Bolivia and % of GDP of Papua New Guinea?
Ensure brevity in your answer.  -6.51. In the year 1996, what is the difference between the % of GDP in Myanmar and % of GDP in Papua New Guinea?
Provide a short and direct response. -10.49. In the year 1997, what is the difference between the % of GDP in Europe(developing only) and % of GDP in Bolivia?
Your response must be concise. 3.97. In the year 1997, what is the difference between the % of GDP of Europe(developing only) and % of GDP of Myanmar?
Provide a succinct answer. 11.1. In the year 1997, what is the difference between the % of GDP of Europe(developing only) and % of GDP of Papua New Guinea?
Give a very brief answer. 2.54. In the year 1997, what is the difference between the % of GDP in Bolivia and % of GDP in Myanmar?
Give a very brief answer. 7.13. In the year 1997, what is the difference between the % of GDP of Bolivia and % of GDP of Papua New Guinea?
Make the answer very short. -1.43. In the year 1997, what is the difference between the % of GDP of Myanmar and % of GDP of Papua New Guinea?
Provide a succinct answer. -8.56. What is the ratio of the % of GDP in Europe(developing only) in 1990 to that in 1991?
Your answer should be very brief. 1.09. What is the ratio of the % of GDP in Bolivia in 1990 to that in 1991?
Provide a short and direct response. 0.8. What is the ratio of the % of GDP of Myanmar in 1990 to that in 1991?
Offer a very short reply. 0.87. What is the ratio of the % of GDP of Papua New Guinea in 1990 to that in 1991?
Provide a short and direct response. 0.89. What is the ratio of the % of GDP of Europe(developing only) in 1990 to that in 1992?
Your response must be concise. 1.03. What is the ratio of the % of GDP in Bolivia in 1990 to that in 1992?
Your answer should be compact. 0.75. What is the ratio of the % of GDP in Myanmar in 1990 to that in 1992?
Give a very brief answer. 0.99. What is the ratio of the % of GDP of Papua New Guinea in 1990 to that in 1992?
Your response must be concise. 1.05. What is the ratio of the % of GDP of Europe(developing only) in 1990 to that in 1993?
Offer a very short reply. 0.96. What is the ratio of the % of GDP of Bolivia in 1990 to that in 1993?
Provide a succinct answer. 0.76. What is the ratio of the % of GDP in Myanmar in 1990 to that in 1993?
Your answer should be compact. 1.08. What is the ratio of the % of GDP in Papua New Guinea in 1990 to that in 1993?
Provide a succinct answer. 1.39. What is the ratio of the % of GDP of Europe(developing only) in 1990 to that in 1994?
Your response must be concise. 1.13. What is the ratio of the % of GDP in Bolivia in 1990 to that in 1994?
Provide a short and direct response. 0.87. What is the ratio of the % of GDP of Myanmar in 1990 to that in 1994?
Your answer should be compact. 1.08. What is the ratio of the % of GDP of Papua New Guinea in 1990 to that in 1994?
Offer a very short reply. 1.14. What is the ratio of the % of GDP in Europe(developing only) in 1990 to that in 1995?
Offer a terse response. 1.09. What is the ratio of the % of GDP in Bolivia in 1990 to that in 1995?
Provide a succinct answer. 0.82. What is the ratio of the % of GDP of Myanmar in 1990 to that in 1995?
Keep it short and to the point. 0.94. What is the ratio of the % of GDP of Papua New Guinea in 1990 to that in 1995?
Make the answer very short. 1.11. What is the ratio of the % of GDP of Europe(developing only) in 1990 to that in 1996?
Make the answer very short. 1.1. What is the ratio of the % of GDP in Bolivia in 1990 to that in 1996?
Provide a short and direct response. 0.77. What is the ratio of the % of GDP of Myanmar in 1990 to that in 1996?
Offer a terse response. 1.09. What is the ratio of the % of GDP in Papua New Guinea in 1990 to that in 1996?
Your answer should be compact. 1.07. What is the ratio of the % of GDP of Europe(developing only) in 1990 to that in 1997?
Ensure brevity in your answer.  1.11. What is the ratio of the % of GDP of Bolivia in 1990 to that in 1997?
Provide a short and direct response. 0.64. What is the ratio of the % of GDP of Myanmar in 1990 to that in 1997?
Your answer should be very brief. 1.07. What is the ratio of the % of GDP of Papua New Guinea in 1990 to that in 1997?
Provide a short and direct response. 1.16. What is the ratio of the % of GDP of Europe(developing only) in 1991 to that in 1992?
Your answer should be very brief. 0.94. What is the ratio of the % of GDP in Bolivia in 1991 to that in 1992?
Provide a short and direct response. 0.93. What is the ratio of the % of GDP of Myanmar in 1991 to that in 1992?
Your answer should be compact. 1.13. What is the ratio of the % of GDP of Papua New Guinea in 1991 to that in 1992?
Your response must be concise. 1.18. What is the ratio of the % of GDP in Europe(developing only) in 1991 to that in 1993?
Your answer should be compact. 0.88. What is the ratio of the % of GDP of Bolivia in 1991 to that in 1993?
Offer a very short reply. 0.94. What is the ratio of the % of GDP of Myanmar in 1991 to that in 1993?
Give a very brief answer. 1.23. What is the ratio of the % of GDP of Papua New Guinea in 1991 to that in 1993?
Your answer should be compact. 1.55. What is the ratio of the % of GDP of Europe(developing only) in 1991 to that in 1994?
Make the answer very short. 1.03. What is the ratio of the % of GDP of Bolivia in 1991 to that in 1994?
Offer a terse response. 1.08. What is the ratio of the % of GDP of Myanmar in 1991 to that in 1994?
Your answer should be very brief. 1.24. What is the ratio of the % of GDP in Papua New Guinea in 1991 to that in 1994?
Offer a terse response. 1.28. What is the ratio of the % of GDP in Europe(developing only) in 1991 to that in 1995?
Keep it short and to the point. 0.99. What is the ratio of the % of GDP of Bolivia in 1991 to that in 1995?
Ensure brevity in your answer.  1.02. What is the ratio of the % of GDP in Myanmar in 1991 to that in 1995?
Offer a very short reply. 1.08. What is the ratio of the % of GDP of Papua New Guinea in 1991 to that in 1995?
Ensure brevity in your answer.  1.25. What is the ratio of the % of GDP of Europe(developing only) in 1991 to that in 1996?
Offer a very short reply. 1.01. What is the ratio of the % of GDP of Bolivia in 1991 to that in 1996?
Provide a succinct answer. 0.96. What is the ratio of the % of GDP in Myanmar in 1991 to that in 1996?
Your response must be concise. 1.25. What is the ratio of the % of GDP of Papua New Guinea in 1991 to that in 1996?
Your answer should be very brief. 1.2. What is the ratio of the % of GDP in Europe(developing only) in 1991 to that in 1997?
Offer a very short reply. 1.01. What is the ratio of the % of GDP in Bolivia in 1991 to that in 1997?
Offer a terse response. 0.79. What is the ratio of the % of GDP in Myanmar in 1991 to that in 1997?
Offer a very short reply. 1.22. What is the ratio of the % of GDP of Papua New Guinea in 1991 to that in 1997?
Provide a succinct answer. 1.3. What is the ratio of the % of GDP in Europe(developing only) in 1992 to that in 1993?
Make the answer very short. 0.94. What is the ratio of the % of GDP in Bolivia in 1992 to that in 1993?
Make the answer very short. 1.01. What is the ratio of the % of GDP of Myanmar in 1992 to that in 1993?
Make the answer very short. 1.09. What is the ratio of the % of GDP of Papua New Guinea in 1992 to that in 1993?
Offer a very short reply. 1.32. What is the ratio of the % of GDP in Europe(developing only) in 1992 to that in 1994?
Your answer should be compact. 1.1. What is the ratio of the % of GDP in Bolivia in 1992 to that in 1994?
Provide a short and direct response. 1.16. What is the ratio of the % of GDP in Myanmar in 1992 to that in 1994?
Give a very brief answer. 1.1. What is the ratio of the % of GDP of Papua New Guinea in 1992 to that in 1994?
Your answer should be very brief. 1.09. What is the ratio of the % of GDP in Europe(developing only) in 1992 to that in 1995?
Give a very brief answer. 1.06. What is the ratio of the % of GDP in Bolivia in 1992 to that in 1995?
Make the answer very short. 1.1. What is the ratio of the % of GDP of Myanmar in 1992 to that in 1995?
Your answer should be very brief. 0.95. What is the ratio of the % of GDP in Papua New Guinea in 1992 to that in 1995?
Keep it short and to the point. 1.06. What is the ratio of the % of GDP of Europe(developing only) in 1992 to that in 1996?
Keep it short and to the point. 1.07. What is the ratio of the % of GDP of Bolivia in 1992 to that in 1996?
Provide a succinct answer. 1.03. What is the ratio of the % of GDP of Myanmar in 1992 to that in 1996?
Offer a terse response. 1.11. What is the ratio of the % of GDP of Papua New Guinea in 1992 to that in 1996?
Offer a terse response. 1.02. What is the ratio of the % of GDP of Europe(developing only) in 1992 to that in 1997?
Offer a very short reply. 1.08. What is the ratio of the % of GDP in Bolivia in 1992 to that in 1997?
Give a very brief answer. 0.85. What is the ratio of the % of GDP in Myanmar in 1992 to that in 1997?
Offer a very short reply. 1.08. What is the ratio of the % of GDP of Papua New Guinea in 1992 to that in 1997?
Offer a very short reply. 1.11. What is the ratio of the % of GDP of Europe(developing only) in 1993 to that in 1994?
Keep it short and to the point. 1.17. What is the ratio of the % of GDP in Bolivia in 1993 to that in 1994?
Give a very brief answer. 1.15. What is the ratio of the % of GDP in Myanmar in 1993 to that in 1994?
Provide a succinct answer. 1.01. What is the ratio of the % of GDP in Papua New Guinea in 1993 to that in 1994?
Your answer should be very brief. 0.83. What is the ratio of the % of GDP in Europe(developing only) in 1993 to that in 1995?
Ensure brevity in your answer.  1.13. What is the ratio of the % of GDP of Bolivia in 1993 to that in 1995?
Offer a very short reply. 1.09. What is the ratio of the % of GDP in Myanmar in 1993 to that in 1995?
Your answer should be very brief. 0.87. What is the ratio of the % of GDP of Papua New Guinea in 1993 to that in 1995?
Provide a short and direct response. 0.8. What is the ratio of the % of GDP of Europe(developing only) in 1993 to that in 1996?
Ensure brevity in your answer.  1.14. What is the ratio of the % of GDP in Bolivia in 1993 to that in 1996?
Offer a terse response. 1.02. What is the ratio of the % of GDP of Myanmar in 1993 to that in 1996?
Make the answer very short. 1.02. What is the ratio of the % of GDP of Papua New Guinea in 1993 to that in 1996?
Offer a very short reply. 0.78. What is the ratio of the % of GDP of Europe(developing only) in 1993 to that in 1997?
Your answer should be compact. 1.15. What is the ratio of the % of GDP in Bolivia in 1993 to that in 1997?
Offer a very short reply. 0.84. What is the ratio of the % of GDP in Myanmar in 1993 to that in 1997?
Your answer should be very brief. 1. What is the ratio of the % of GDP in Papua New Guinea in 1993 to that in 1997?
Provide a succinct answer. 0.84. What is the ratio of the % of GDP in Europe(developing only) in 1994 to that in 1995?
Your response must be concise. 0.96. What is the ratio of the % of GDP of Bolivia in 1994 to that in 1995?
Your answer should be very brief. 0.94. What is the ratio of the % of GDP in Myanmar in 1994 to that in 1995?
Make the answer very short. 0.87. What is the ratio of the % of GDP of Papua New Guinea in 1994 to that in 1995?
Ensure brevity in your answer.  0.97. What is the ratio of the % of GDP of Europe(developing only) in 1994 to that in 1996?
Make the answer very short. 0.98. What is the ratio of the % of GDP of Bolivia in 1994 to that in 1996?
Offer a terse response. 0.89. What is the ratio of the % of GDP in Myanmar in 1994 to that in 1996?
Keep it short and to the point. 1.01. What is the ratio of the % of GDP of Papua New Guinea in 1994 to that in 1996?
Your response must be concise. 0.94. What is the ratio of the % of GDP of Europe(developing only) in 1994 to that in 1997?
Offer a terse response. 0.98. What is the ratio of the % of GDP of Bolivia in 1994 to that in 1997?
Offer a terse response. 0.73. What is the ratio of the % of GDP of Myanmar in 1994 to that in 1997?
Give a very brief answer. 0.99. What is the ratio of the % of GDP in Papua New Guinea in 1994 to that in 1997?
Make the answer very short. 1.01. What is the ratio of the % of GDP in Europe(developing only) in 1995 to that in 1996?
Provide a succinct answer. 1.01. What is the ratio of the % of GDP of Bolivia in 1995 to that in 1996?
Your response must be concise. 0.94. What is the ratio of the % of GDP of Myanmar in 1995 to that in 1996?
Your answer should be very brief. 1.16. What is the ratio of the % of GDP of Papua New Guinea in 1995 to that in 1996?
Ensure brevity in your answer.  0.96. What is the ratio of the % of GDP in Europe(developing only) in 1995 to that in 1997?
Your response must be concise. 1.02. What is the ratio of the % of GDP in Bolivia in 1995 to that in 1997?
Provide a short and direct response. 0.78. What is the ratio of the % of GDP in Myanmar in 1995 to that in 1997?
Your answer should be compact. 1.14. What is the ratio of the % of GDP in Papua New Guinea in 1995 to that in 1997?
Offer a very short reply. 1.04. What is the ratio of the % of GDP of Bolivia in 1996 to that in 1997?
Your answer should be very brief. 0.83. What is the ratio of the % of GDP of Myanmar in 1996 to that in 1997?
Provide a short and direct response. 0.98. What is the ratio of the % of GDP in Papua New Guinea in 1996 to that in 1997?
Provide a short and direct response. 1.08. What is the difference between the highest and the second highest % of GDP in Europe(developing only)?
Your answer should be compact. 0.99. What is the difference between the highest and the second highest % of GDP in Bolivia?
Make the answer very short. 2.93. What is the difference between the highest and the second highest % of GDP in Myanmar?
Provide a short and direct response. 1.07. What is the difference between the highest and the second highest % of GDP of Papua New Guinea?
Your answer should be compact. 2.96. What is the difference between the highest and the lowest % of GDP of Europe(developing only)?
Make the answer very short. 3.92. What is the difference between the highest and the lowest % of GDP in Bolivia?
Offer a terse response. 7.1. What is the difference between the highest and the lowest % of GDP in Myanmar?
Offer a very short reply. 3.06. What is the difference between the highest and the lowest % of GDP in Papua New Guinea?
Your response must be concise. 9.77. 